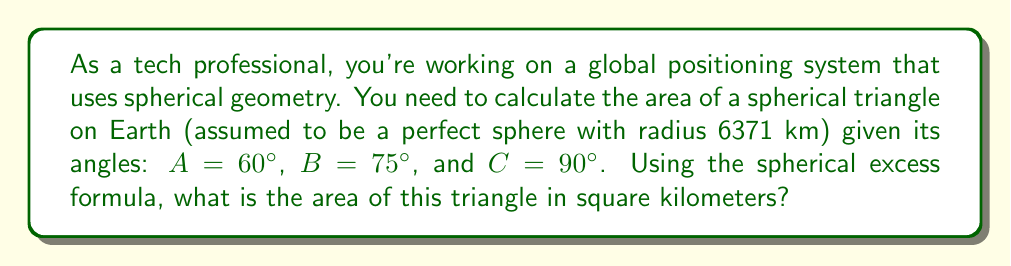Help me with this question. Let's approach this step-by-step:

1) The spherical excess formula for the area of a spherical triangle is:

   $$A = R^2 \cdot E$$

   Where $A$ is the area, $R$ is the radius of the sphere, and $E$ is the spherical excess in radians.

2) The spherical excess $E$ is given by:

   $$E = A + B + C - \pi$$

   Where $A$, $B$, and $C$ are the angles of the spherical triangle in radians.

3) First, let's convert the given angles to radians:

   $A = 60° = \frac{\pi}{3}$ radians
   $B = 75° = \frac{5\pi}{12}$ radians
   $C = 90° = \frac{\pi}{2}$ radians

4) Now, let's calculate the spherical excess:

   $$E = \frac{\pi}{3} + \frac{5\pi}{12} + \frac{\pi}{2} - \pi = \frac{\pi}{4}$$ radians

5) We can now use the spherical excess formula:

   $$A = R^2 \cdot E = (6371)^2 \cdot \frac{\pi}{4} \approx 31,865,681.72$$ km²

Therefore, the area of the spherical triangle is approximately 31,865,681.72 square kilometers.
Answer: 31,865,681.72 km² 